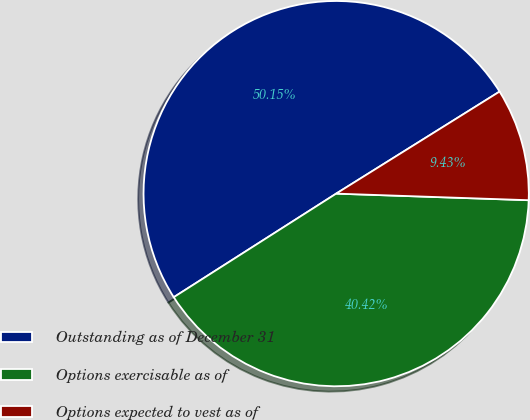Convert chart to OTSL. <chart><loc_0><loc_0><loc_500><loc_500><pie_chart><fcel>Outstanding as of December 31<fcel>Options exercisable as of<fcel>Options expected to vest as of<nl><fcel>50.15%<fcel>40.42%<fcel>9.43%<nl></chart> 